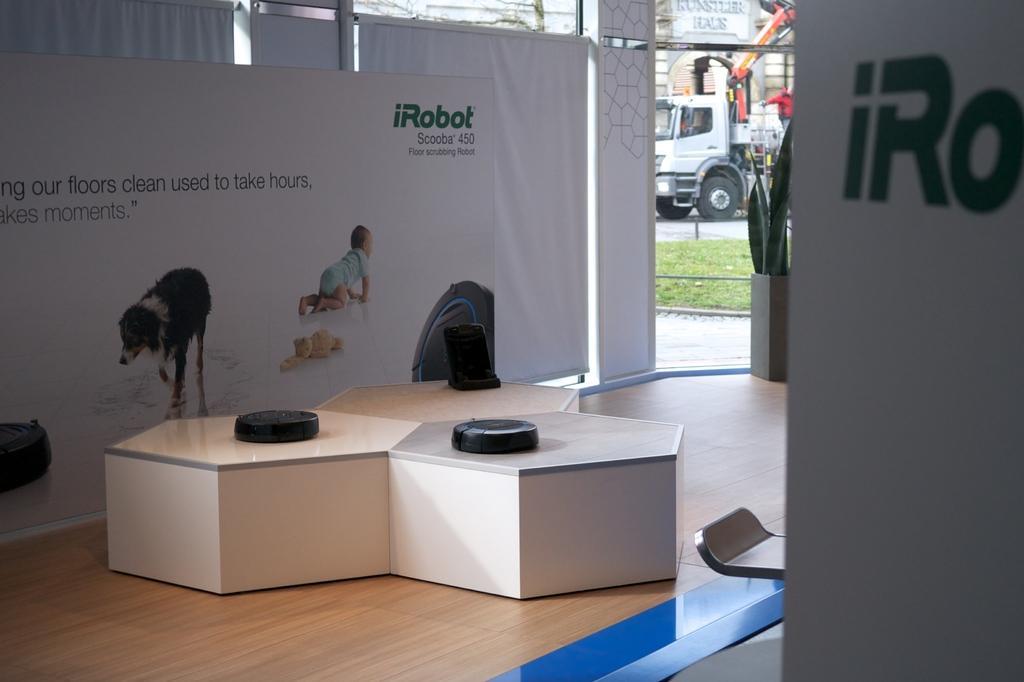Please provide a concise description of this image. In this image, we can see a design table with black objects on the wooden floor. Here we can see hoardings, plants with pot. Background we can see walkway, grass, road and vehicle. 